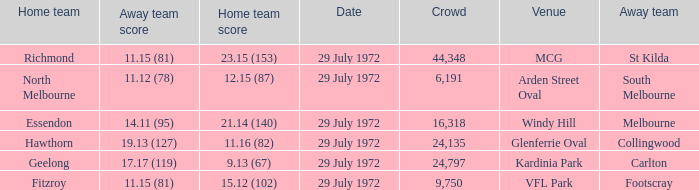When collingwood was the away team, what was the home team? Hawthorn. 